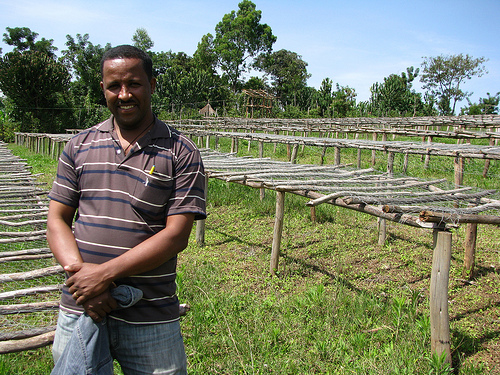<image>
Is the man next to the structure? Yes. The man is positioned adjacent to the structure, located nearby in the same general area. 